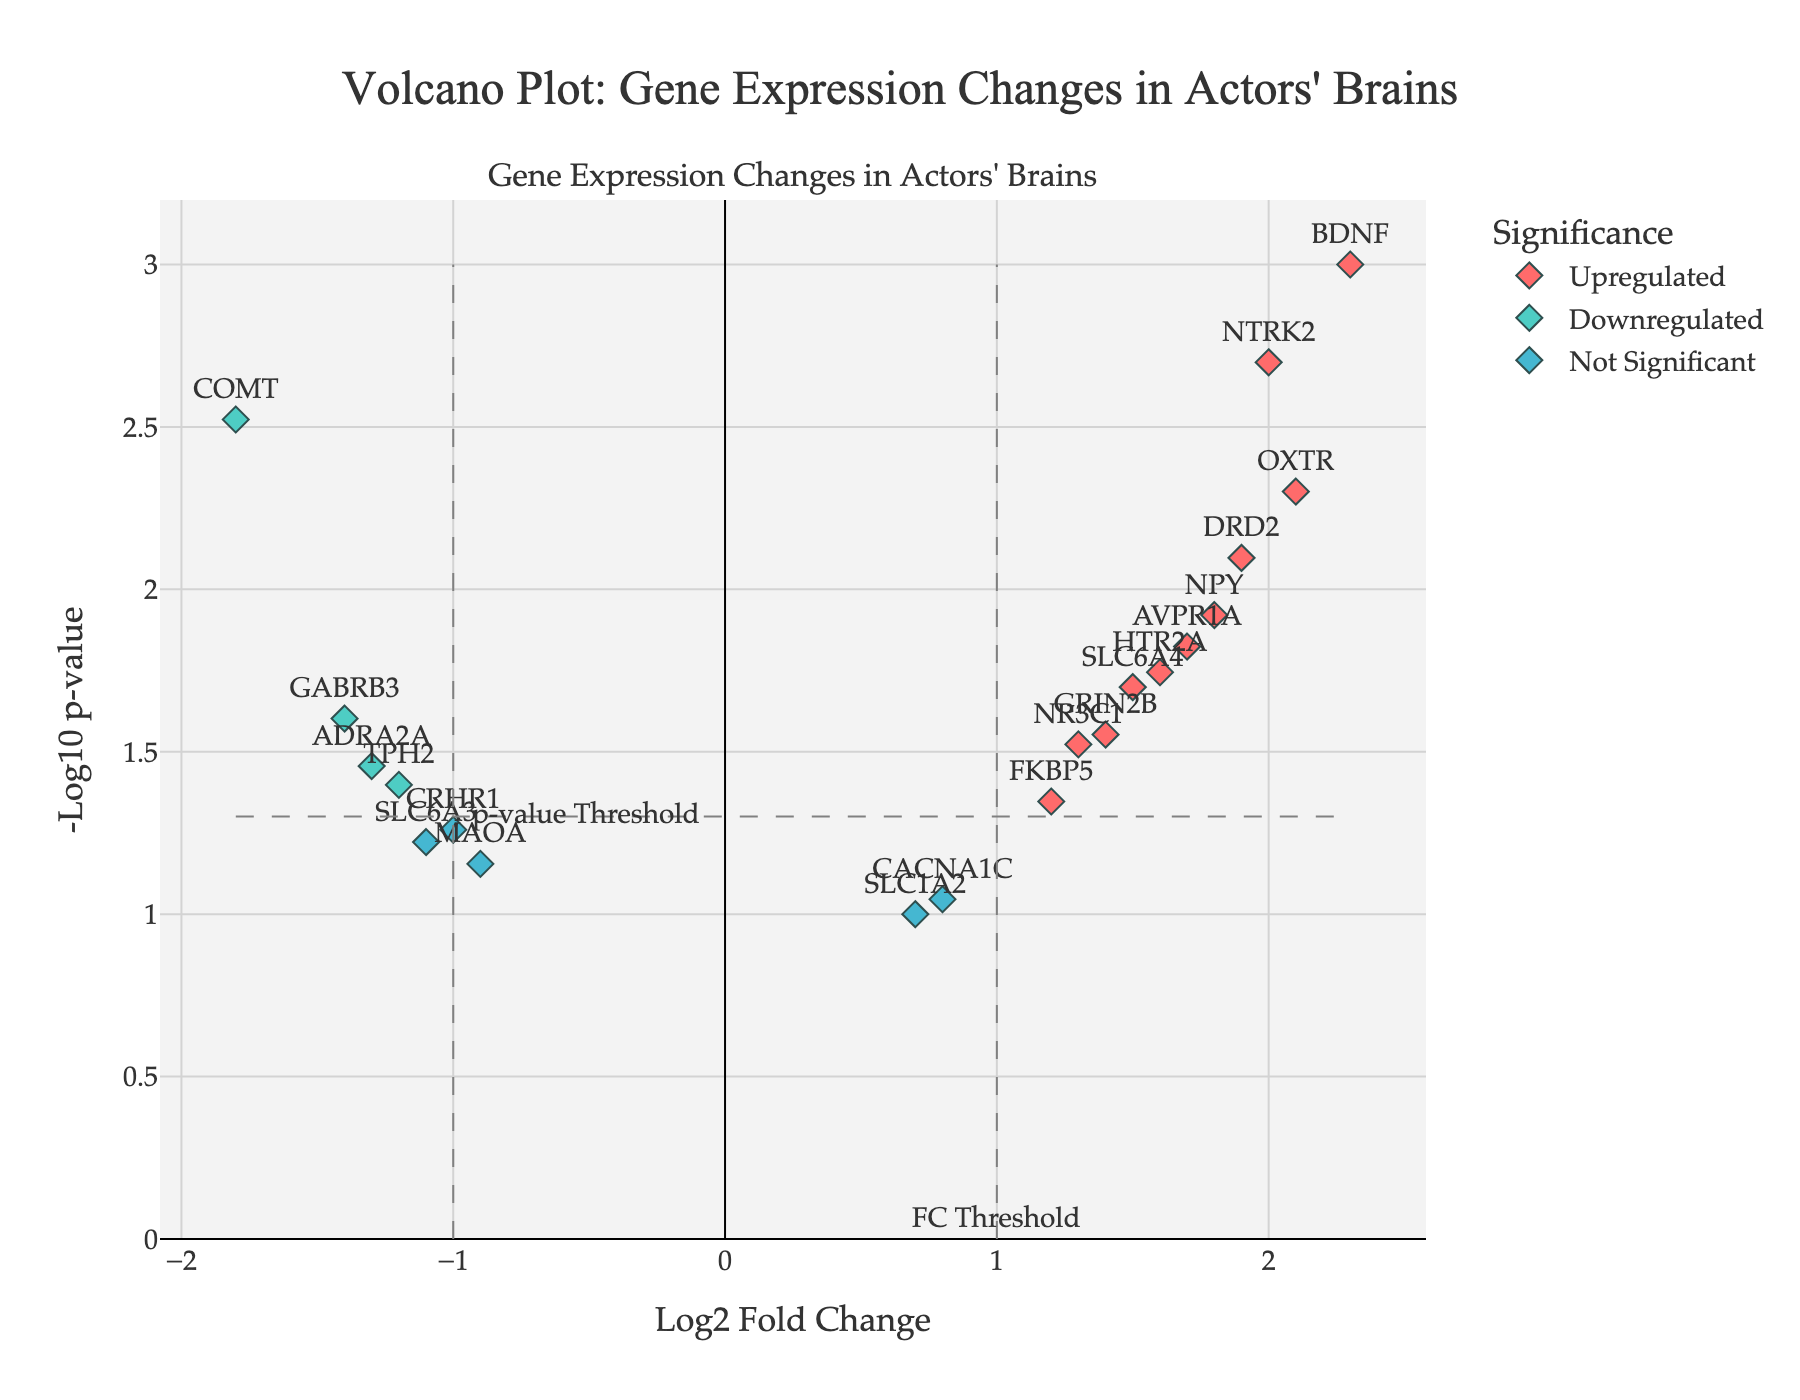What is the title of the plot? The title is displayed at the top center of the figure. It is written in bold, larger font for emphasis.
Answer: Volcano Plot: Gene Expression Changes in Actors' Brains How many genes are under the "Upregulated" category? The upregulated genes are color-coded with a specific color. By counting the number of data points in this color, you can determine the number.
Answer: 9 Which gene has the highest Log2 Fold Change and what is its value? By looking for the data point farthest to the right, you can identify the gene with the highest Log2 Fold Change. Its hover text will give the value.
Answer: BDNF, 2.3 What is the -log10(p-value) of the gene COMT? By finding the gene labeled COMT and checking its y-axis value, you can determine the -log10(p-value).
Answer: 2.52 How many genes have a Log2 Fold Change less than -1 and a p-value smaller than 0.05? Identify the data points on the left side of the threshold line (-1) and below the horizontal p-value threshold. Count these points.
Answer: 2 Which gene has the highest -log10(p-value)? The gene at the highest point on the y-axis will have the highest -log10(p-value). The hover text provides the specific value.
Answer: BDNF How many genes are considered "Not Significant" based on their color category? Genes labeled 'Not Significant' have a specific color. Count these data points to find the total.
Answer: 8 Which genes are most significantly downregulated? The most significantly downregulated genes will have the lowest Log2 Fold Change (most negative) and fall below the p-value threshold. Check their coordinates and labels.
Answer: COMT, GABRB3 What is the -log10(p-value) for the gene with the Log2 Fold Change closest to 0? Find the gene closest to the vertical axis (Log2 Fold Change near zero), then determine its y-axis value for the -log10(p-value).
Answer: CACNA1C, 1.045 Which gene has a Log2 Fold Change of 1.2 and what is its -log10(p-value)? Locate the data point at Log2 Fold Change of 1.2 on the x-axis and find its corresponding -log10(p-value) from the y-axis value.
Answer: FKBP5, 1.347 